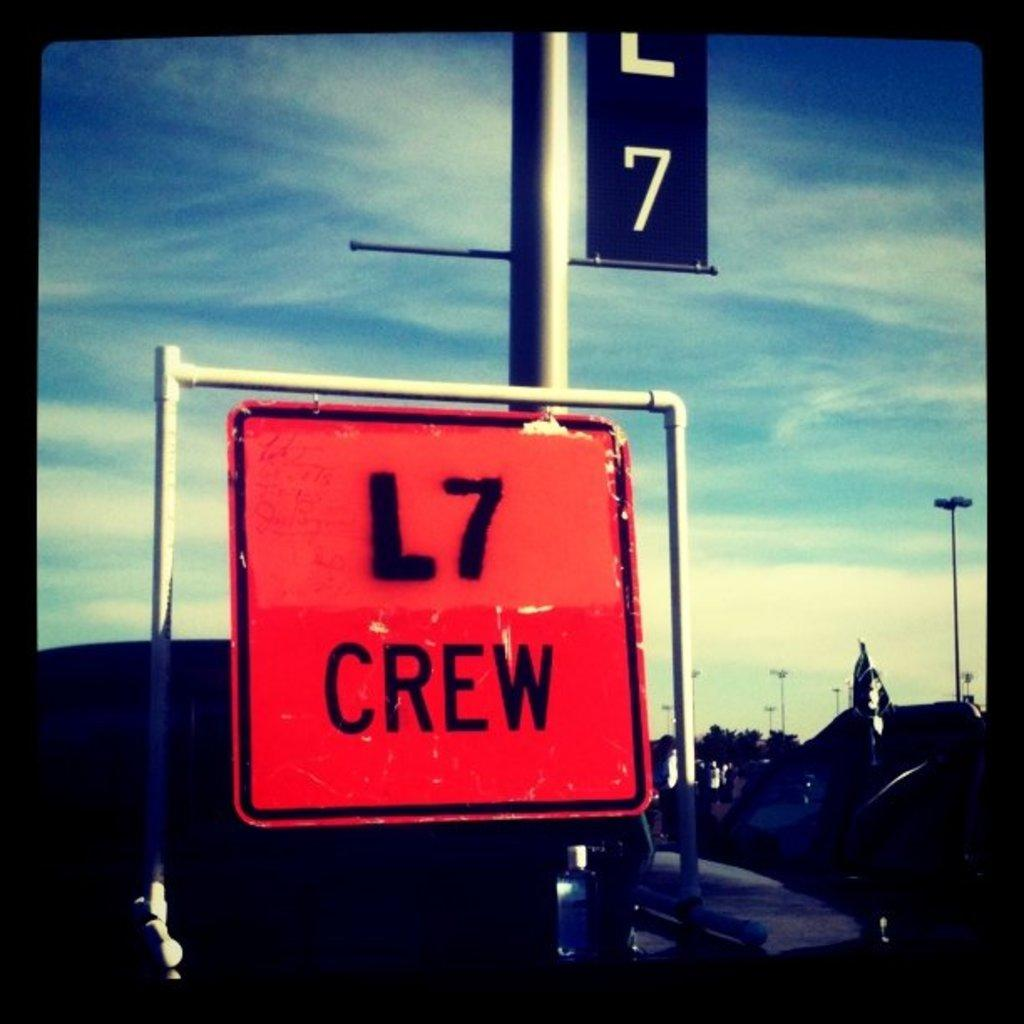<image>
Provide a brief description of the given image. The red sign shown contains the word crew. 